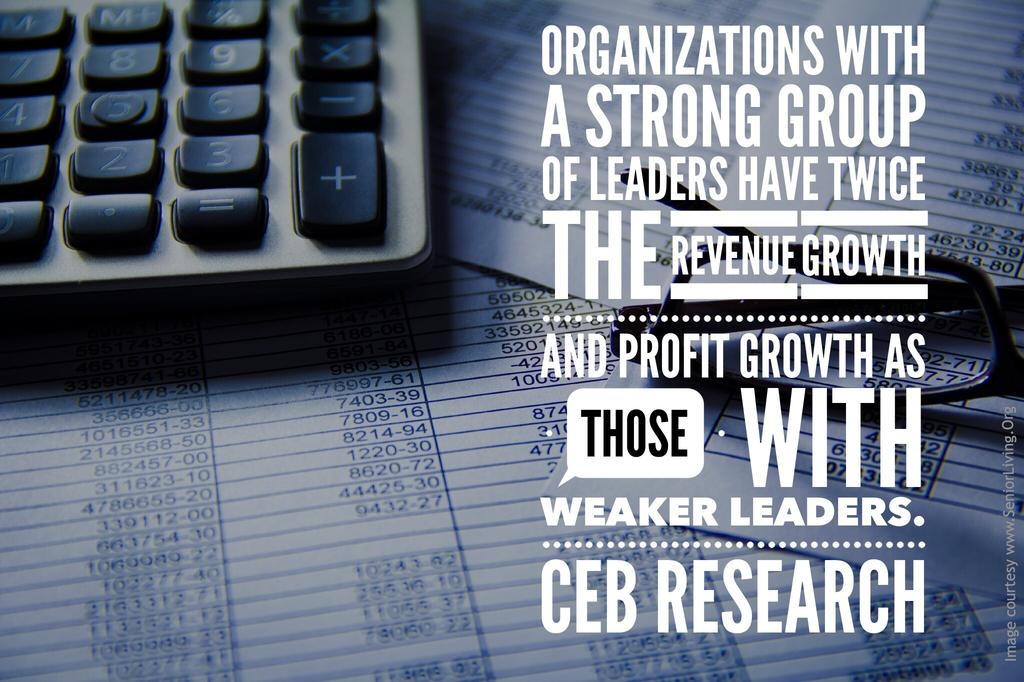<image>
Relay a brief, clear account of the picture shown. An advertisement showing a calculator on top of spreadsheets with text talking about strong leaders versus weak leaders. 